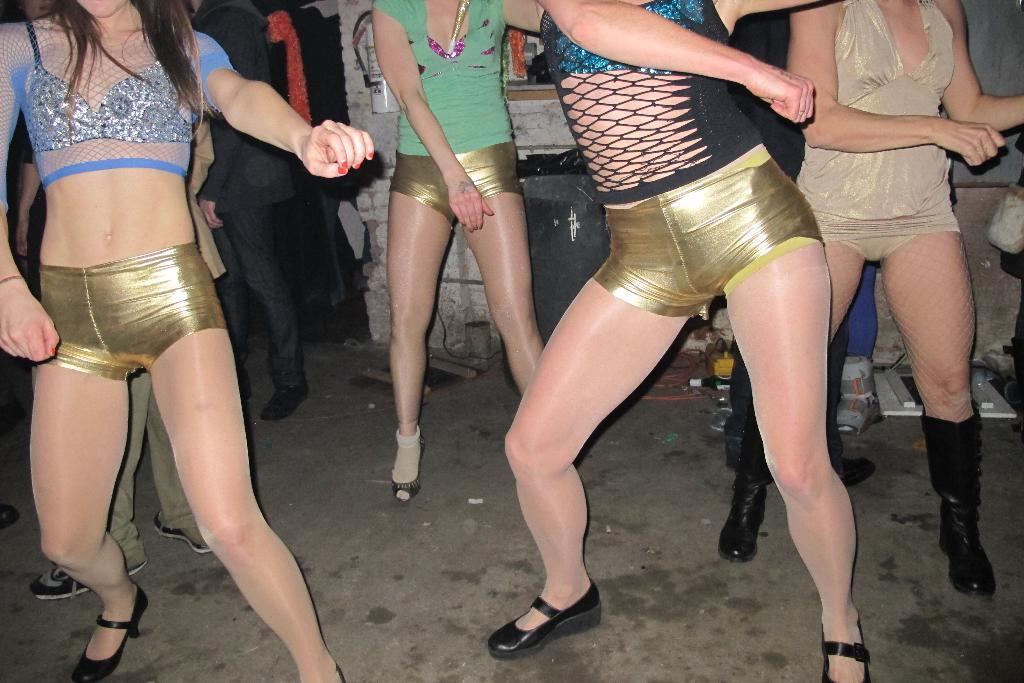What are the women in the image doing? The four women in the image are dancing. What can be seen in the background of the image? There are people standing in the background of the image. Can you describe any specific features of the image? Yes, there appears to be a wall in the image, and there is an object that is black in color. How many ants can be seen carrying a stick in the image? There are no ants or sticks present in the image. What type of milk is being served to the women in the image? There is no milk present in the image; it features four women dancing. 